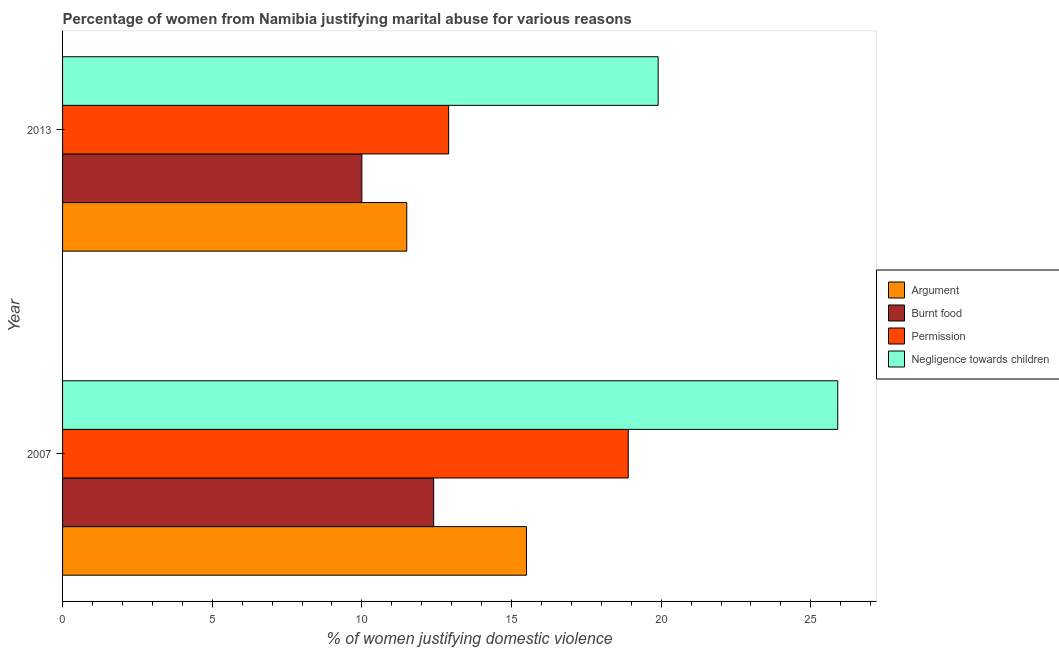How many different coloured bars are there?
Provide a succinct answer. 4. How many bars are there on the 2nd tick from the top?
Provide a short and direct response. 4. What is the label of the 2nd group of bars from the top?
Keep it short and to the point. 2007. In which year was the percentage of women justifying abuse for burning food minimum?
Provide a succinct answer. 2013. What is the total percentage of women justifying abuse for burning food in the graph?
Your answer should be compact. 22.4. What is the difference between the percentage of women justifying abuse for going without permission in 2007 and the percentage of women justifying abuse for showing negligence towards children in 2013?
Give a very brief answer. -1. What is the average percentage of women justifying abuse for burning food per year?
Offer a very short reply. 11.2. In how many years, is the percentage of women justifying abuse for going without permission greater than 24 %?
Your answer should be compact. 0. What is the ratio of the percentage of women justifying abuse for going without permission in 2007 to that in 2013?
Give a very brief answer. 1.47. Is the percentage of women justifying abuse in the case of an argument in 2007 less than that in 2013?
Ensure brevity in your answer.  No. Is the difference between the percentage of women justifying abuse for showing negligence towards children in 2007 and 2013 greater than the difference between the percentage of women justifying abuse in the case of an argument in 2007 and 2013?
Ensure brevity in your answer.  Yes. In how many years, is the percentage of women justifying abuse for burning food greater than the average percentage of women justifying abuse for burning food taken over all years?
Make the answer very short. 1. Is it the case that in every year, the sum of the percentage of women justifying abuse for burning food and percentage of women justifying abuse in the case of an argument is greater than the sum of percentage of women justifying abuse for going without permission and percentage of women justifying abuse for showing negligence towards children?
Your answer should be compact. No. What does the 4th bar from the top in 2007 represents?
Keep it short and to the point. Argument. What does the 3rd bar from the bottom in 2013 represents?
Make the answer very short. Permission. How many years are there in the graph?
Ensure brevity in your answer.  2. Are the values on the major ticks of X-axis written in scientific E-notation?
Your answer should be very brief. No. Where does the legend appear in the graph?
Offer a very short reply. Center right. How many legend labels are there?
Keep it short and to the point. 4. What is the title of the graph?
Ensure brevity in your answer.  Percentage of women from Namibia justifying marital abuse for various reasons. What is the label or title of the X-axis?
Ensure brevity in your answer.  % of women justifying domestic violence. What is the label or title of the Y-axis?
Offer a very short reply. Year. What is the % of women justifying domestic violence in Argument in 2007?
Make the answer very short. 15.5. What is the % of women justifying domestic violence of Burnt food in 2007?
Your answer should be compact. 12.4. What is the % of women justifying domestic violence of Permission in 2007?
Provide a short and direct response. 18.9. What is the % of women justifying domestic violence in Negligence towards children in 2007?
Provide a succinct answer. 25.9. What is the % of women justifying domestic violence of Argument in 2013?
Keep it short and to the point. 11.5. What is the % of women justifying domestic violence of Permission in 2013?
Your answer should be very brief. 12.9. Across all years, what is the maximum % of women justifying domestic violence in Argument?
Provide a succinct answer. 15.5. Across all years, what is the maximum % of women justifying domestic violence in Permission?
Your answer should be very brief. 18.9. Across all years, what is the maximum % of women justifying domestic violence in Negligence towards children?
Your answer should be very brief. 25.9. Across all years, what is the minimum % of women justifying domestic violence of Argument?
Your answer should be compact. 11.5. Across all years, what is the minimum % of women justifying domestic violence of Burnt food?
Your response must be concise. 10. Across all years, what is the minimum % of women justifying domestic violence of Negligence towards children?
Make the answer very short. 19.9. What is the total % of women justifying domestic violence in Argument in the graph?
Make the answer very short. 27. What is the total % of women justifying domestic violence in Burnt food in the graph?
Keep it short and to the point. 22.4. What is the total % of women justifying domestic violence in Permission in the graph?
Offer a terse response. 31.8. What is the total % of women justifying domestic violence in Negligence towards children in the graph?
Your response must be concise. 45.8. What is the difference between the % of women justifying domestic violence of Burnt food in 2007 and that in 2013?
Make the answer very short. 2.4. What is the difference between the % of women justifying domestic violence of Negligence towards children in 2007 and that in 2013?
Give a very brief answer. 6. What is the difference between the % of women justifying domestic violence of Argument in 2007 and the % of women justifying domestic violence of Permission in 2013?
Make the answer very short. 2.6. What is the difference between the % of women justifying domestic violence of Burnt food in 2007 and the % of women justifying domestic violence of Permission in 2013?
Your response must be concise. -0.5. What is the average % of women justifying domestic violence of Argument per year?
Ensure brevity in your answer.  13.5. What is the average % of women justifying domestic violence in Burnt food per year?
Provide a succinct answer. 11.2. What is the average % of women justifying domestic violence of Permission per year?
Give a very brief answer. 15.9. What is the average % of women justifying domestic violence in Negligence towards children per year?
Offer a very short reply. 22.9. In the year 2007, what is the difference between the % of women justifying domestic violence of Argument and % of women justifying domestic violence of Burnt food?
Ensure brevity in your answer.  3.1. In the year 2007, what is the difference between the % of women justifying domestic violence in Argument and % of women justifying domestic violence in Permission?
Your answer should be compact. -3.4. In the year 2007, what is the difference between the % of women justifying domestic violence in Burnt food and % of women justifying domestic violence in Permission?
Keep it short and to the point. -6.5. In the year 2007, what is the difference between the % of women justifying domestic violence in Burnt food and % of women justifying domestic violence in Negligence towards children?
Your answer should be very brief. -13.5. In the year 2007, what is the difference between the % of women justifying domestic violence of Permission and % of women justifying domestic violence of Negligence towards children?
Your response must be concise. -7. In the year 2013, what is the difference between the % of women justifying domestic violence in Argument and % of women justifying domestic violence in Permission?
Keep it short and to the point. -1.4. In the year 2013, what is the difference between the % of women justifying domestic violence in Burnt food and % of women justifying domestic violence in Permission?
Keep it short and to the point. -2.9. What is the ratio of the % of women justifying domestic violence in Argument in 2007 to that in 2013?
Give a very brief answer. 1.35. What is the ratio of the % of women justifying domestic violence in Burnt food in 2007 to that in 2013?
Offer a terse response. 1.24. What is the ratio of the % of women justifying domestic violence of Permission in 2007 to that in 2013?
Keep it short and to the point. 1.47. What is the ratio of the % of women justifying domestic violence of Negligence towards children in 2007 to that in 2013?
Your answer should be compact. 1.3. What is the difference between the highest and the lowest % of women justifying domestic violence of Burnt food?
Your answer should be very brief. 2.4. What is the difference between the highest and the lowest % of women justifying domestic violence of Permission?
Provide a succinct answer. 6. What is the difference between the highest and the lowest % of women justifying domestic violence in Negligence towards children?
Give a very brief answer. 6. 